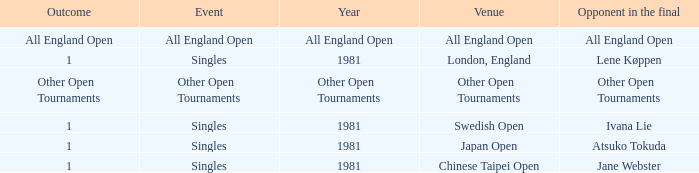I'm looking to parse the entire table for insights. Could you assist me with that? {'header': ['Outcome', 'Event', 'Year', 'Venue', 'Opponent in the final'], 'rows': [['All England Open', 'All England Open', 'All England Open', 'All England Open', 'All England Open'], ['1', 'Singles', '1981', 'London, England', 'Lene Køppen'], ['Other Open Tournaments', 'Other Open Tournaments', 'Other Open Tournaments', 'Other Open Tournaments', 'Other Open Tournaments'], ['1', 'Singles', '1981', 'Swedish Open', 'Ivana Lie'], ['1', 'Singles', '1981', 'Japan Open', 'Atsuko Tokuda'], ['1', 'Singles', '1981', 'Chinese Taipei Open', 'Jane Webster']]} What is the Opponent in final with an All England Open Outcome? All England Open. 